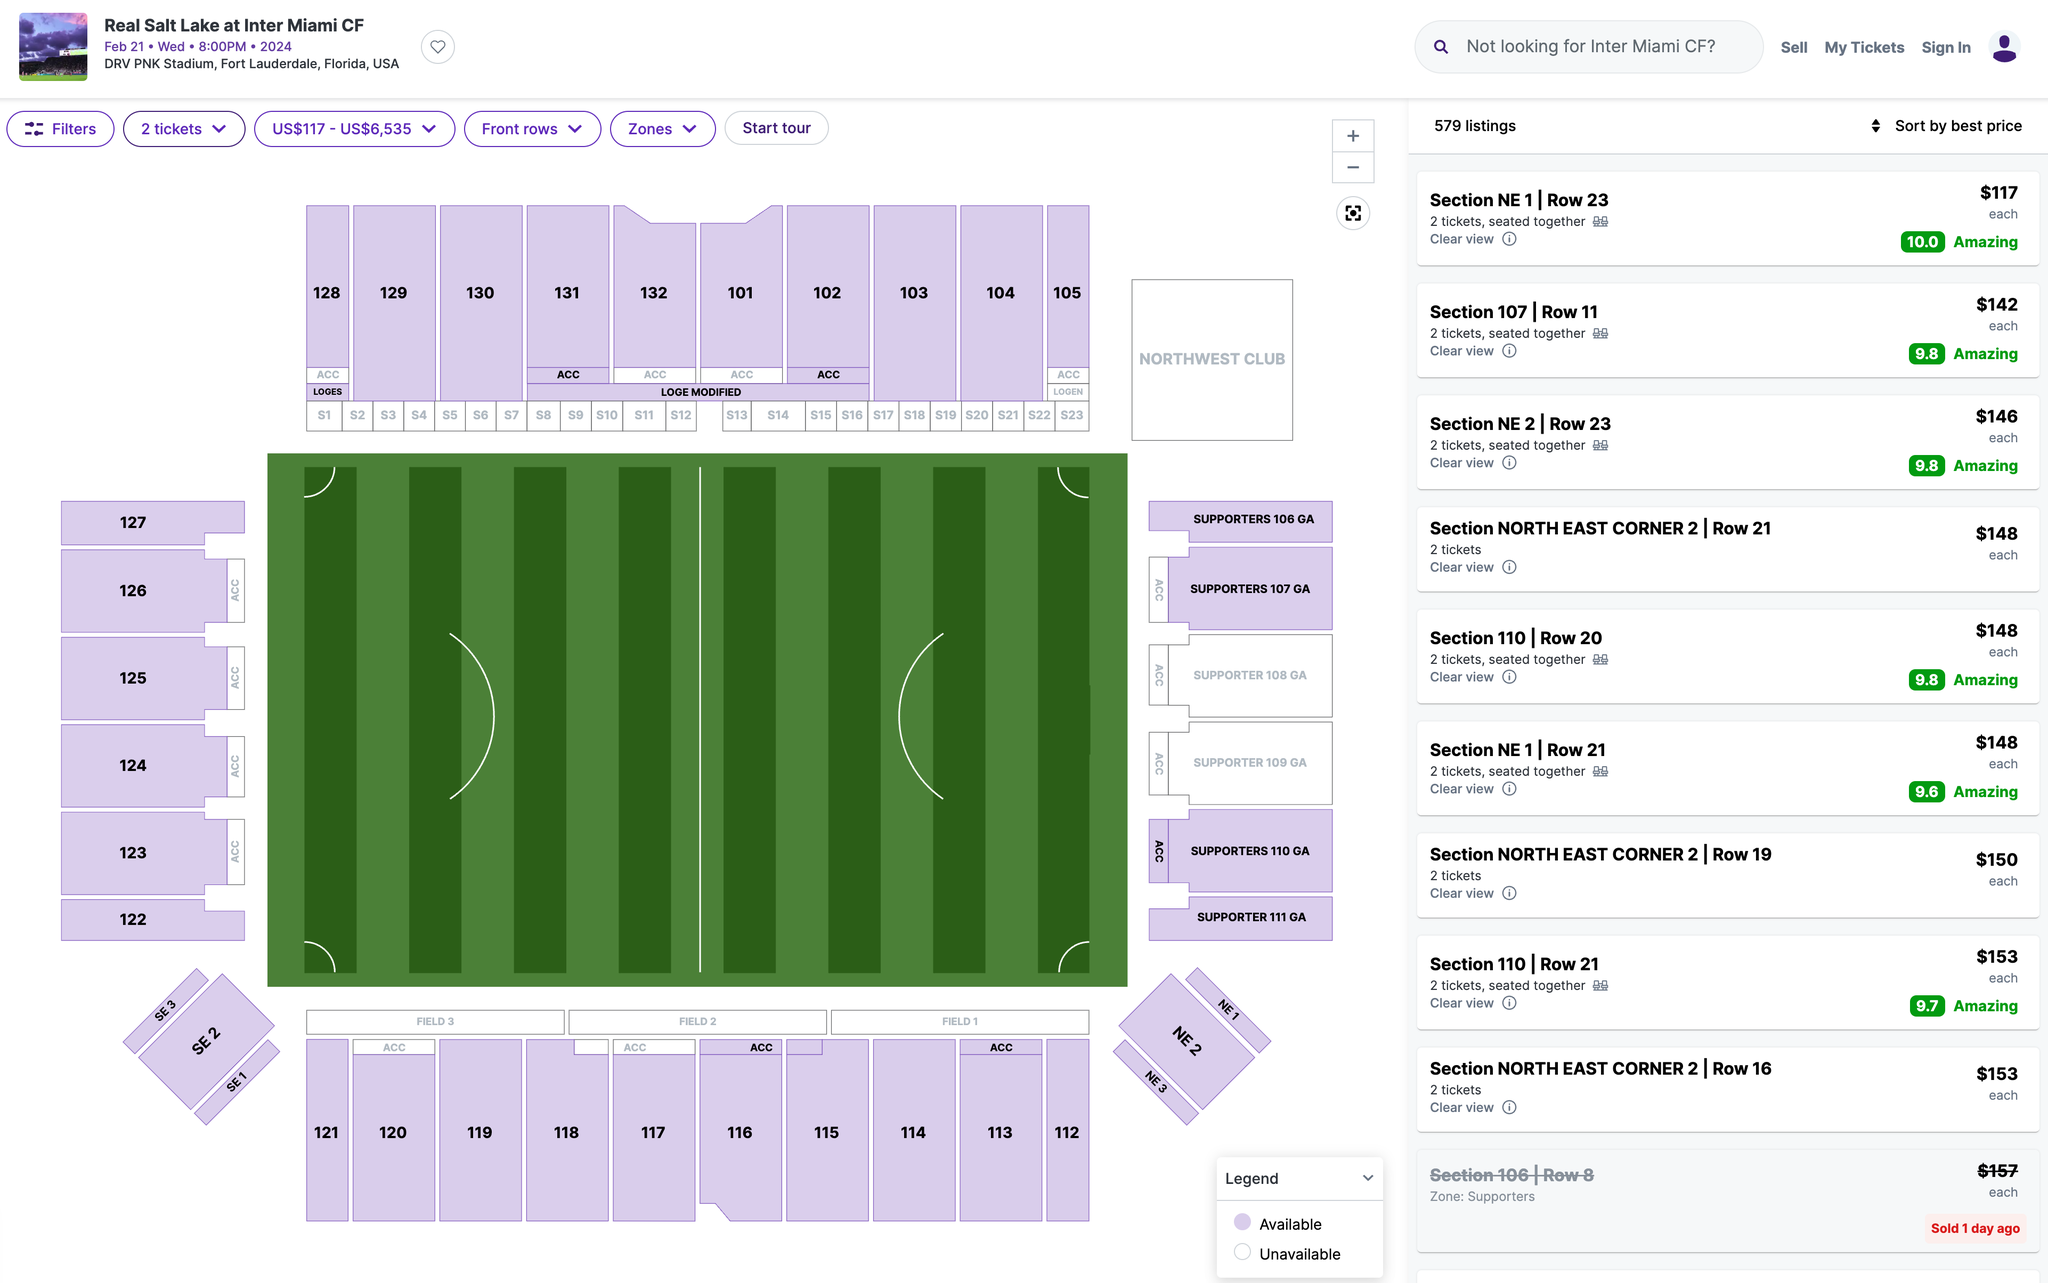Which section's ticket would you recommend I purchase? Based on the seating chart and ticket listings shown, I would recommend purchasing tickets in Section NE 21 Row 23. These tickets are priced at $146 each and are listed as having an "Amazing" clear view rating. They are located near the middle of the venue, providing a reasonably close and centered perspective of the event or performance taking place. Given the balance of their relatively affordable price and highly rated sightlines, Section NE 21 Row 23 seems to offer good value among the available options displayed. 